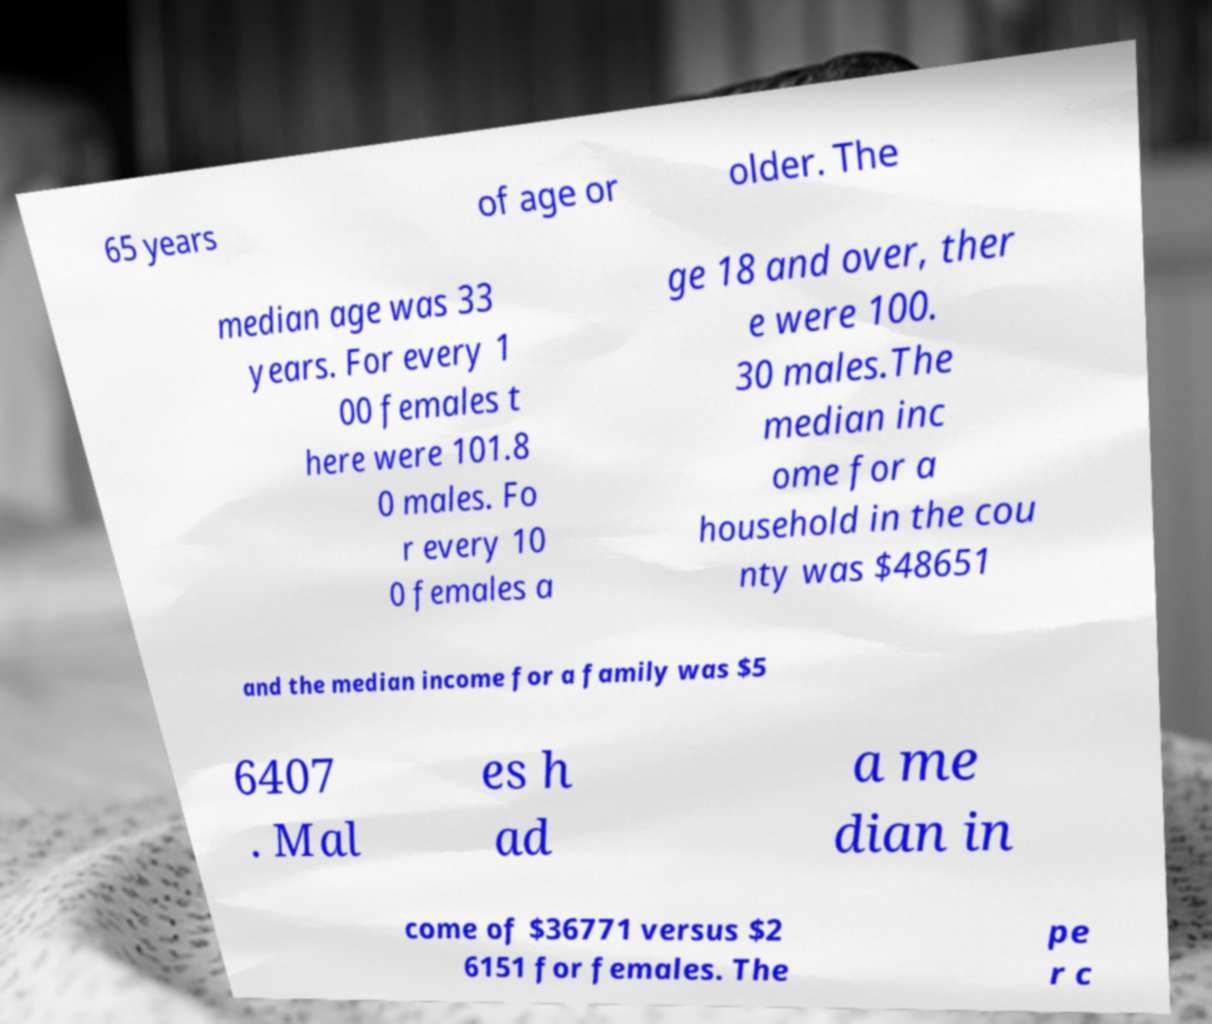Please identify and transcribe the text found in this image. 65 years of age or older. The median age was 33 years. For every 1 00 females t here were 101.8 0 males. Fo r every 10 0 females a ge 18 and over, ther e were 100. 30 males.The median inc ome for a household in the cou nty was $48651 and the median income for a family was $5 6407 . Mal es h ad a me dian in come of $36771 versus $2 6151 for females. The pe r c 